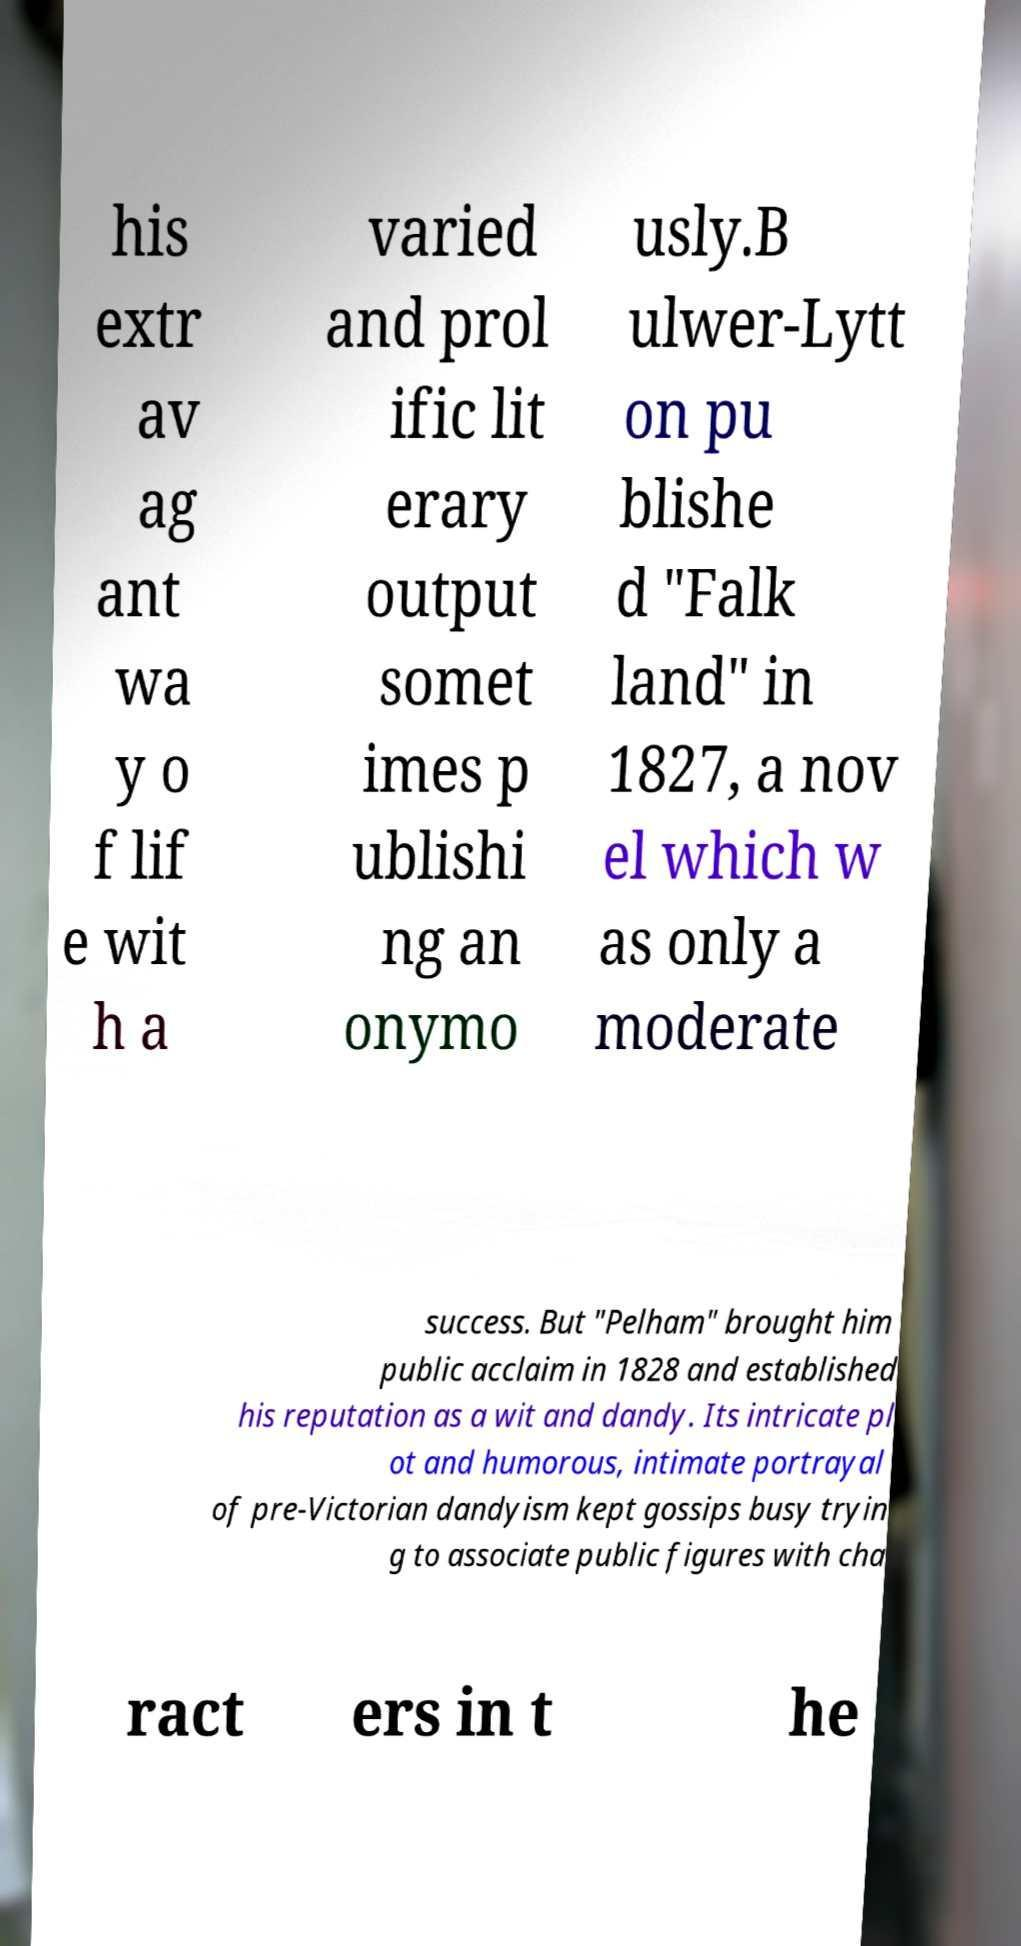What messages or text are displayed in this image? I need them in a readable, typed format. his extr av ag ant wa y o f lif e wit h a varied and prol ific lit erary output somet imes p ublishi ng an onymo usly.B ulwer-Lytt on pu blishe d "Falk land" in 1827, a nov el which w as only a moderate success. But "Pelham" brought him public acclaim in 1828 and established his reputation as a wit and dandy. Its intricate pl ot and humorous, intimate portrayal of pre-Victorian dandyism kept gossips busy tryin g to associate public figures with cha ract ers in t he 